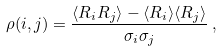Convert formula to latex. <formula><loc_0><loc_0><loc_500><loc_500>\rho ( i , j ) = \frac { \langle { R _ { i } R _ { j } } \rangle - \langle { R _ { i } } \rangle \langle { R _ { j } } \rangle } { \sigma _ { i } \sigma _ { j } } \, ,</formula> 